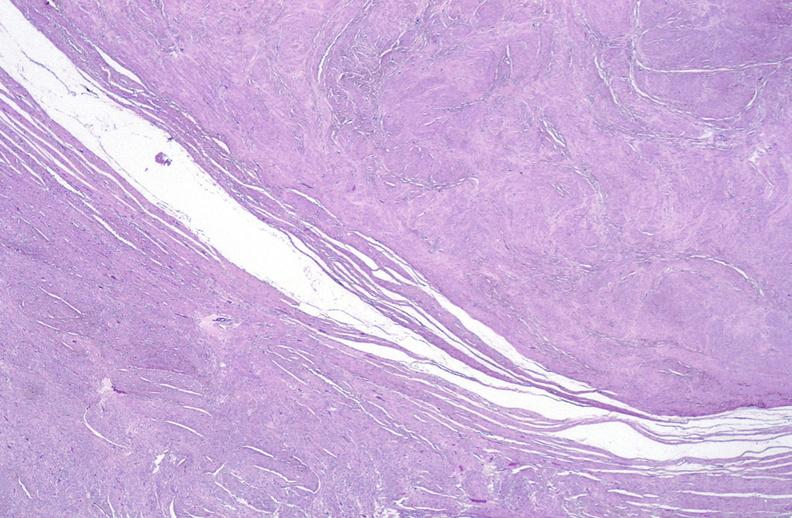what is present?
Answer the question using a single word or phrase. Female reproductive 